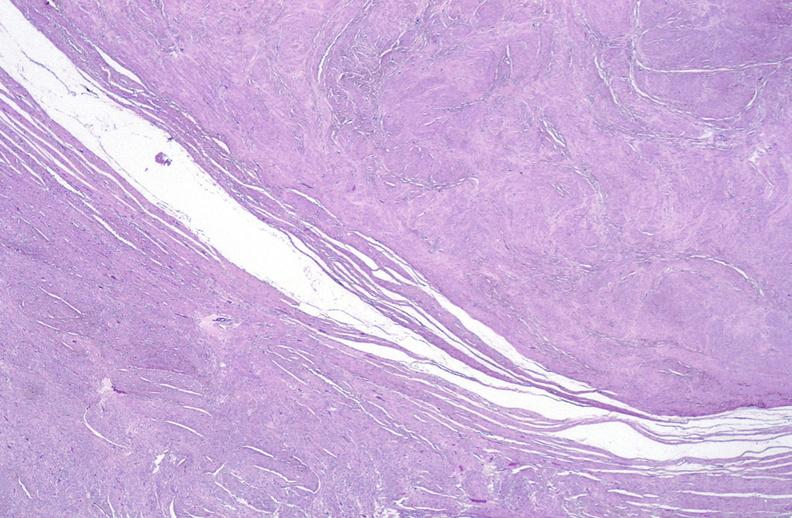what is present?
Answer the question using a single word or phrase. Female reproductive 